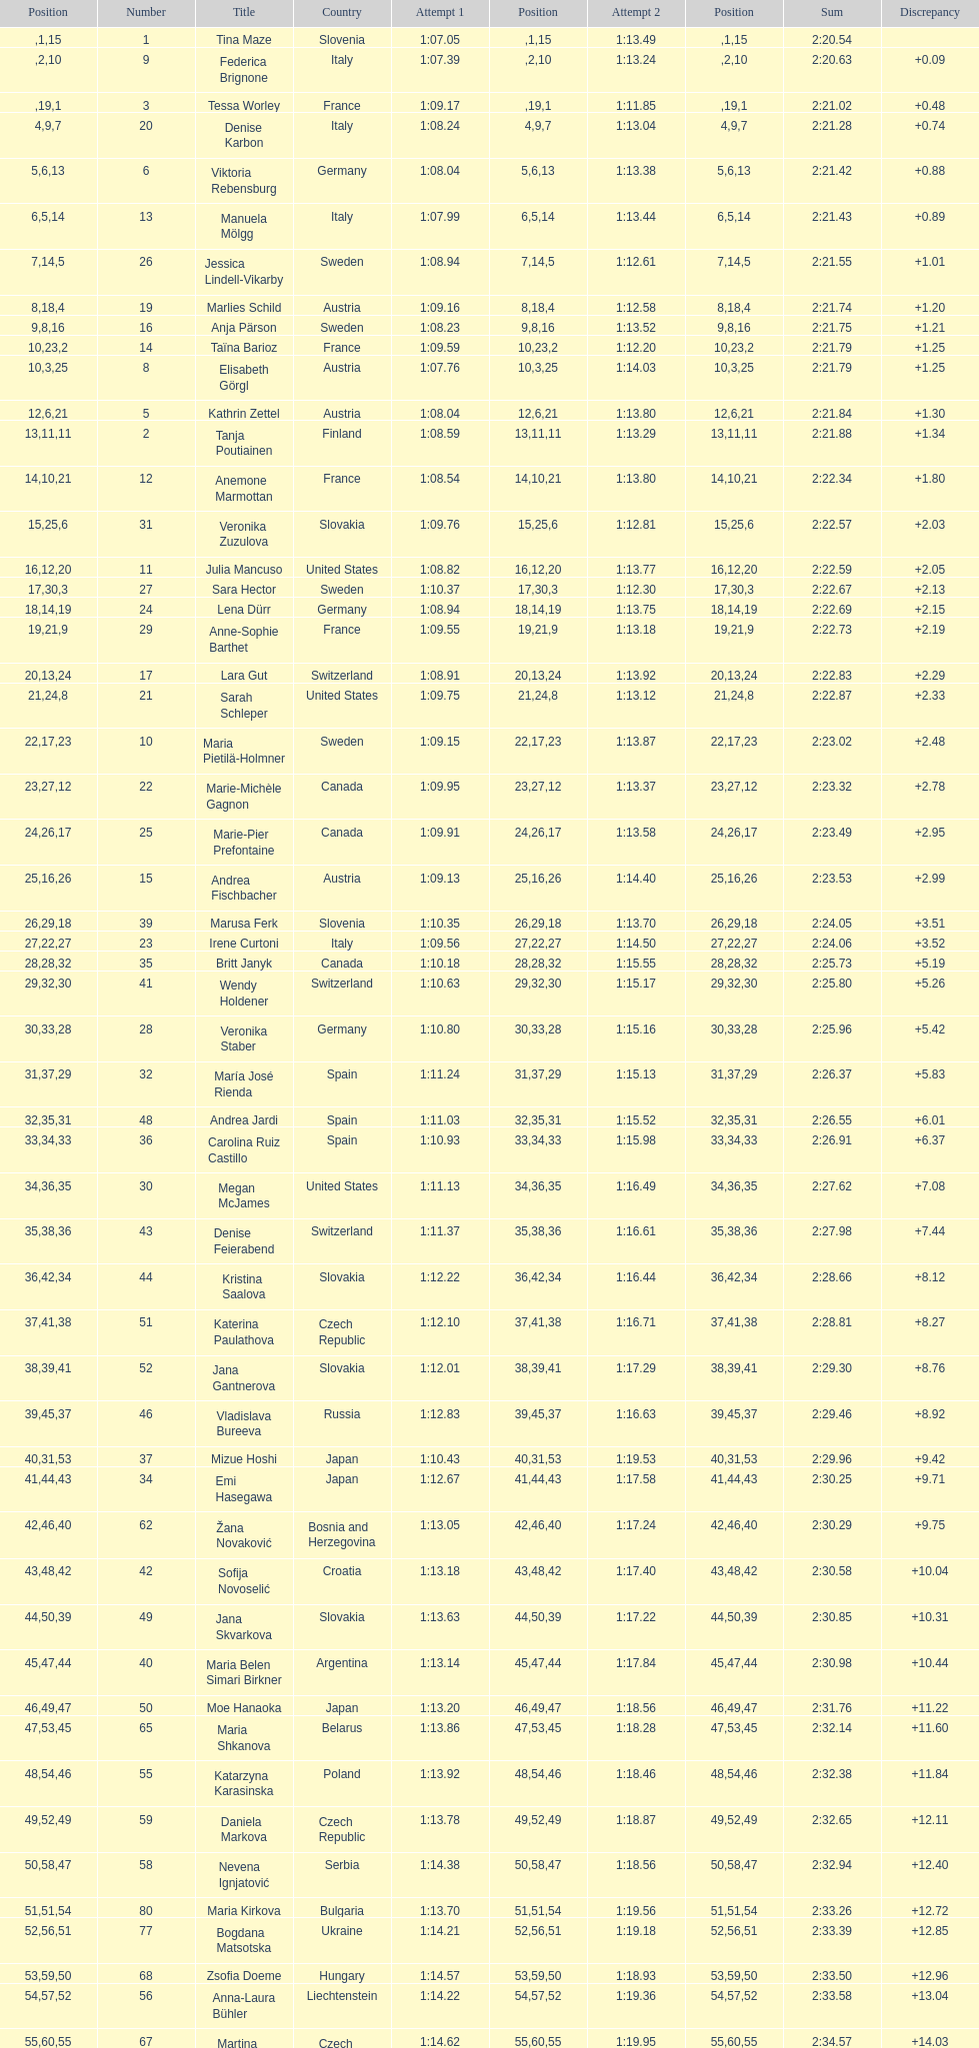Who finished next after federica brignone? Tessa Worley. 